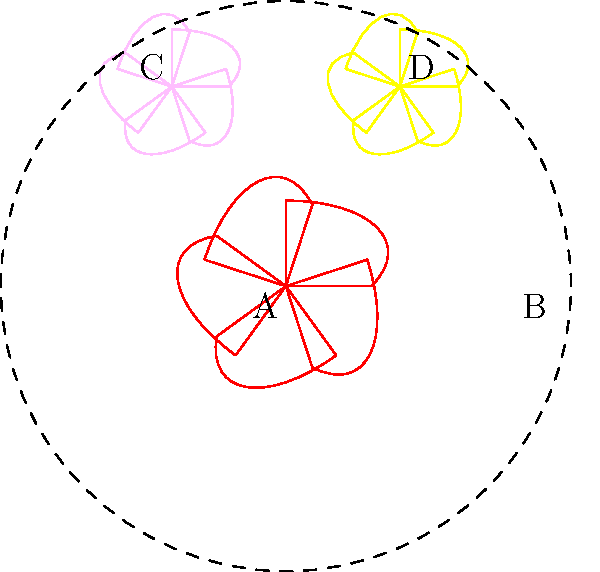In a traditional Catholic wedding bouquet, which flower arrangement typically represents the bride's purity and innocence? To answer this question, let's consider the symbolic meanings of flowers in Catholic tradition and wedding customs:

1. Red flowers (A): Often symbolize love and passion.
2. White flowers (B): Traditionally represent purity, innocence, and virtue.
3. Pink flowers (C): Usually symbolize grace, elegance, and joy.
4. Yellow flowers (D): Commonly represent friendship and new beginnings.

In Catholic wedding traditions, the bride's bouquet often includes white flowers to symbolize her purity and innocence before God. This tradition dates back centuries and is deeply rooted in Catholic symbolism.

The white flowers, represented by arrangement B in the image, are the most fitting choice for this symbolism in a Catholic wedding bouquet.
Answer: White flowers (B) 